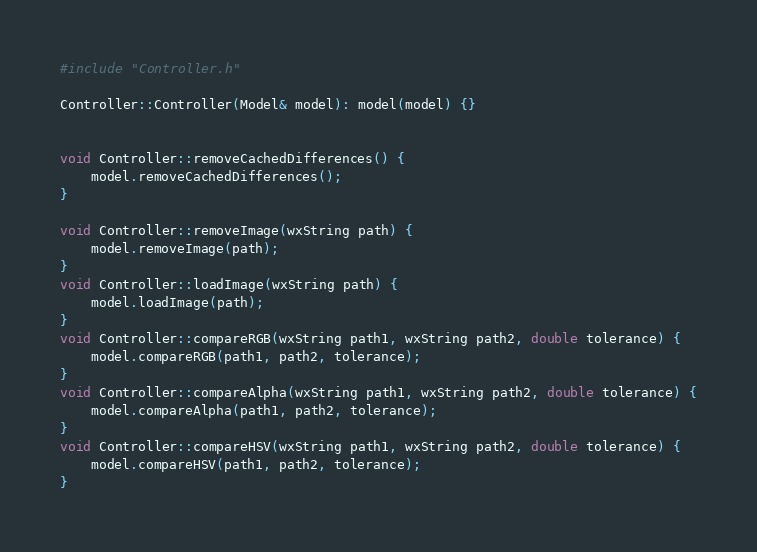<code> <loc_0><loc_0><loc_500><loc_500><_C++_>#include "Controller.h"

Controller::Controller(Model& model): model(model) {}


void Controller::removeCachedDifferences() {
	model.removeCachedDifferences();
}

void Controller::removeImage(wxString path) {
	model.removeImage(path);
}
void Controller::loadImage(wxString path) {
	model.loadImage(path);
}
void Controller::compareRGB(wxString path1, wxString path2, double tolerance) {
	model.compareRGB(path1, path2, tolerance);
}
void Controller::compareAlpha(wxString path1, wxString path2, double tolerance) {
	model.compareAlpha(path1, path2, tolerance);
}
void Controller::compareHSV(wxString path1, wxString path2, double tolerance) {
	model.compareHSV(path1, path2, tolerance);
}
</code> 